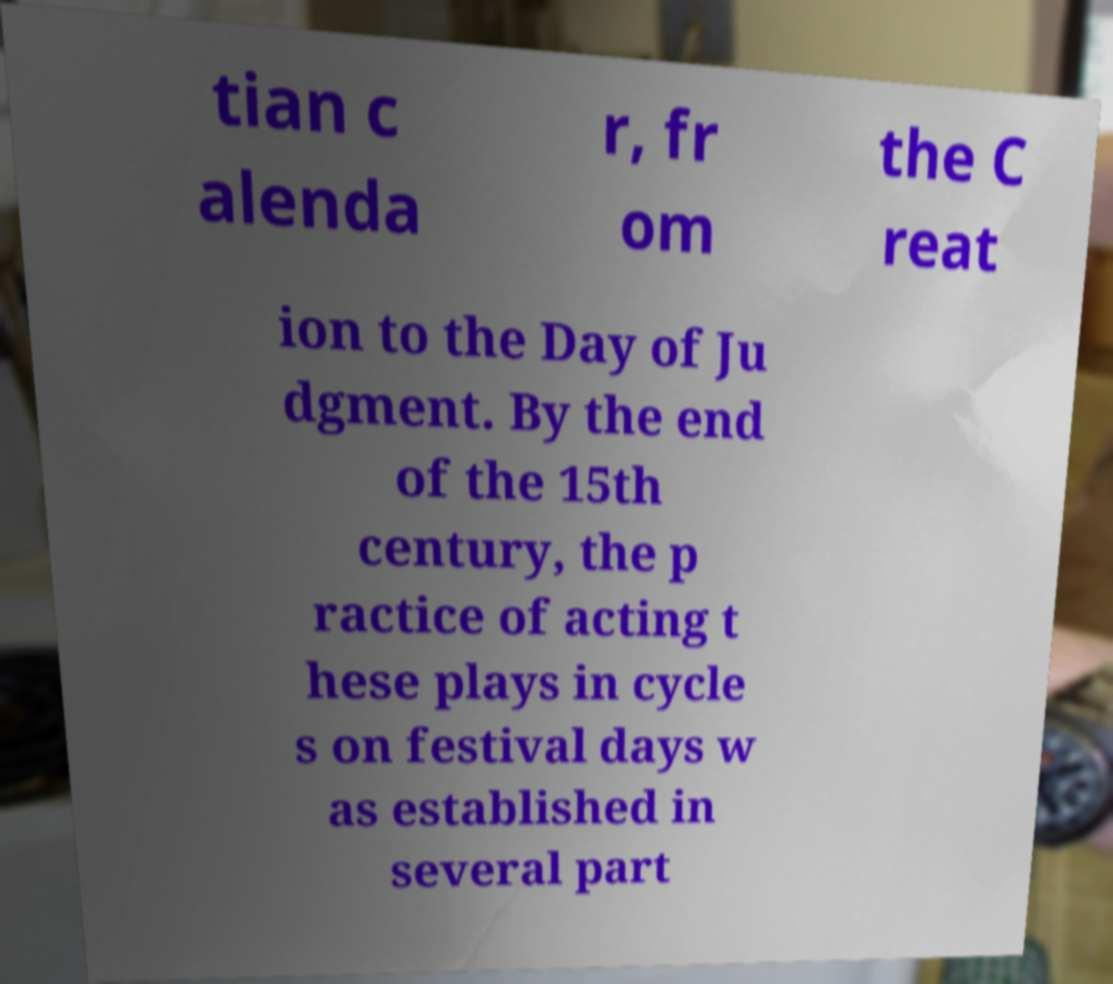Could you extract and type out the text from this image? tian c alenda r, fr om the C reat ion to the Day of Ju dgment. By the end of the 15th century, the p ractice of acting t hese plays in cycle s on festival days w as established in several part 